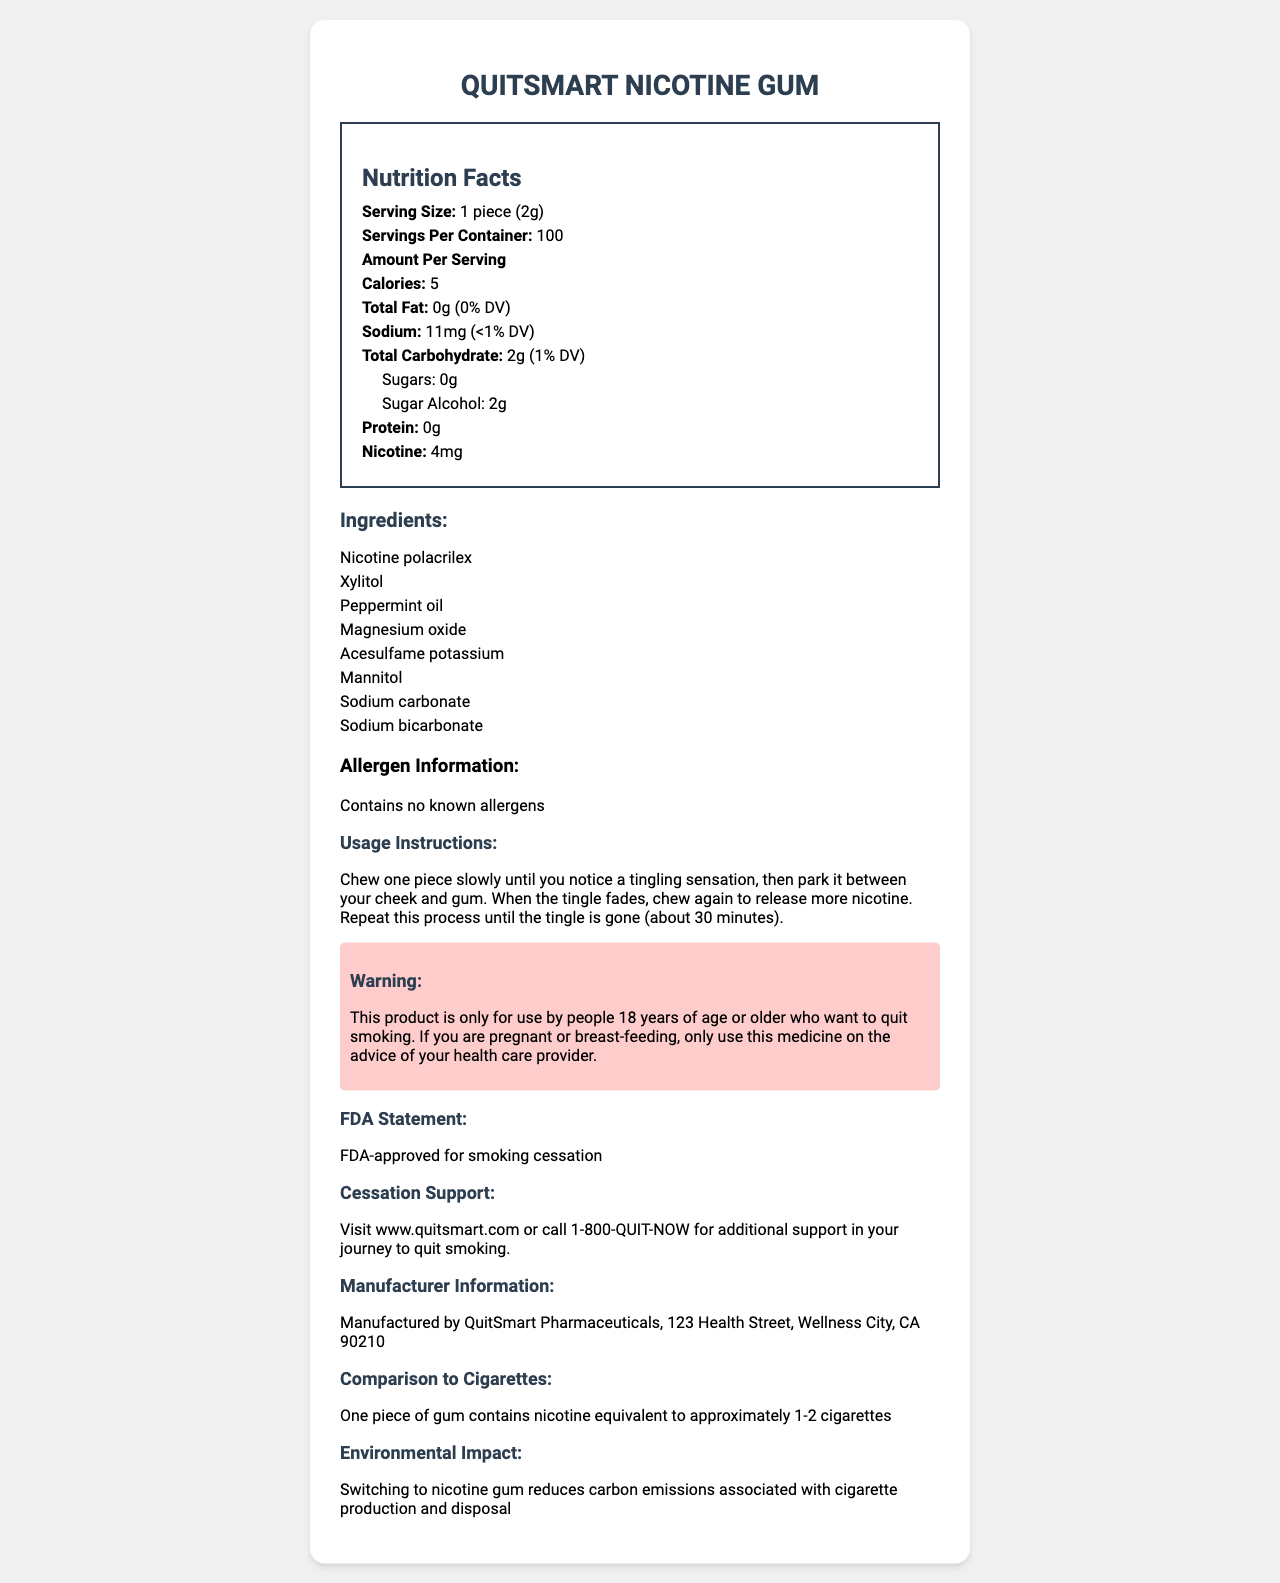what is the serving size of QuitSmart Nicotine Gum? The serving size is clearly listed as "1 piece (2g)" under the nutrition facts section.
Answer: 1 piece (2g) how many servings are there per container of QuitSmart Nicotine Gum? The document specifies that there are 100 servings per container.
Answer: 100 how many calories does each piece of gum contain? The nutrition facts indicate that each serving contains 5 calories.
Answer: 5 what is the sodium content per serving? The sodium content is listed as 11mg per serving under the nutrition facts.
Answer: 11mg how much nicotine is in each piece of gum? The nicotine content per serving is listed as 4mg.
Answer: 4mg does QuitSmart Nicotine Gum contain any sugars? Under the total carbohydrate section, it is stated that sugars are 0g.
Answer: No what sweetener is used in QuitSmart Nicotine Gum? The ingredients list includes Xylitol.
Answer: Xylitol is QuitSmart Nicotine Gum FDA approved for smoking cessation? The FDA statement confirms that the product is FDA-approved for smoking cessation.
Answer: Yes what are some of the additional ingredients in QuitSmart Nicotine Gum? These ingredients are listed under the ingredient list section.
Answer: Peppermint oil, Magnesium oxide, Acesulfame potassium what is the instructed usage method for QuitSmart Nicotine Gum? A. Chew and swallow B. Chew and park between cheek and gum C. Dissolve in water The usage instructions clearly indicate that the piece should be chewed until a tingling sensation is felt and then parked between cheek and gum.
Answer: B what is QuitSmart Nicotine Gum's environmental impact compared to cigarettes? A. Increases carbon emissions B. Reduces carbon emissions C. Has no impact The document states that switching to nicotine gum reduces carbon emissions associated with cigarette production and disposal.
Answer: B should people under 18 years use QuitSmart Nicotine Gum? The warning section specifies that the product is only for use by people 18 years of age or older who want to quit smoking.
Answer: No does the product contain any known allergens? The allergen information confirms that it contains no known allergens.
Answer: No Summarize the document The document provides detailed nutrition facts, ingredients, usage instructions, warnings, and asserts FDA approval, aiming to emphasize its role in helping people quit smoking and its environmental benefits.
Answer: QuitSmart Nicotine Gum is a nicotine replacement product intended to help people quit smoking. Each piece contains 5 calories, 4mg of nicotine, and is free of sugars. It uses Xylitol as a sweetener among other ingredients. It’s FDA-approved for smoking cessation and offers environmental benefits by reducing carbon emissions associated with cigarettes. The product is only for adults 18 and older and contains no known allergens. how much carbohydrate does each serving contain? The total carbohydrate content per serving is listed as 2g in the nutrition facts.
Answer: 2g Can this product be used by pregnant women without consultation? The warning section specifies that pregnant or breast-feeding women should only use this medicine on the advice of a healthcare provider.
Answer: No Which company manufactures QuitSmart Nicotine Gum? The manufacturer information states that it is manufactured by QuitSmart Pharmaceuticals.
Answer: QuitSmart Pharmaceuticals what is the effect of using QuitSmart Nicotine Gum on smoking cessation? While the document provides details about nicotine content and usage instructions, it does not provide statistics or detailed data on its effectiveness in aiding smoking cessation.
Answer: Not enough information 